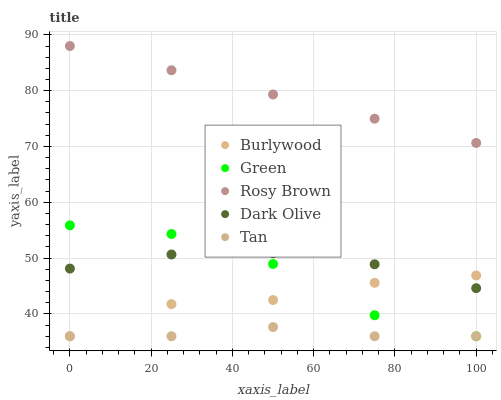Does Tan have the minimum area under the curve?
Answer yes or no. Yes. Does Rosy Brown have the maximum area under the curve?
Answer yes or no. Yes. Does Dark Olive have the minimum area under the curve?
Answer yes or no. No. Does Dark Olive have the maximum area under the curve?
Answer yes or no. No. Is Rosy Brown the smoothest?
Answer yes or no. Yes. Is Green the roughest?
Answer yes or no. Yes. Is Dark Olive the smoothest?
Answer yes or no. No. Is Dark Olive the roughest?
Answer yes or no. No. Does Burlywood have the lowest value?
Answer yes or no. Yes. Does Dark Olive have the lowest value?
Answer yes or no. No. Does Rosy Brown have the highest value?
Answer yes or no. Yes. Does Dark Olive have the highest value?
Answer yes or no. No. Is Burlywood less than Rosy Brown?
Answer yes or no. Yes. Is Rosy Brown greater than Tan?
Answer yes or no. Yes. Does Dark Olive intersect Burlywood?
Answer yes or no. Yes. Is Dark Olive less than Burlywood?
Answer yes or no. No. Is Dark Olive greater than Burlywood?
Answer yes or no. No. Does Burlywood intersect Rosy Brown?
Answer yes or no. No. 